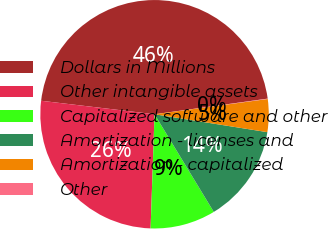Convert chart to OTSL. <chart><loc_0><loc_0><loc_500><loc_500><pie_chart><fcel>Dollars in Millions<fcel>Other intangible assets<fcel>Capitalized software and other<fcel>Amortization - licenses and<fcel>Amortization - capitalized<fcel>Other<nl><fcel>45.94%<fcel>26.34%<fcel>9.23%<fcel>13.82%<fcel>4.64%<fcel>0.05%<nl></chart> 